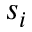<formula> <loc_0><loc_0><loc_500><loc_500>s _ { i }</formula> 